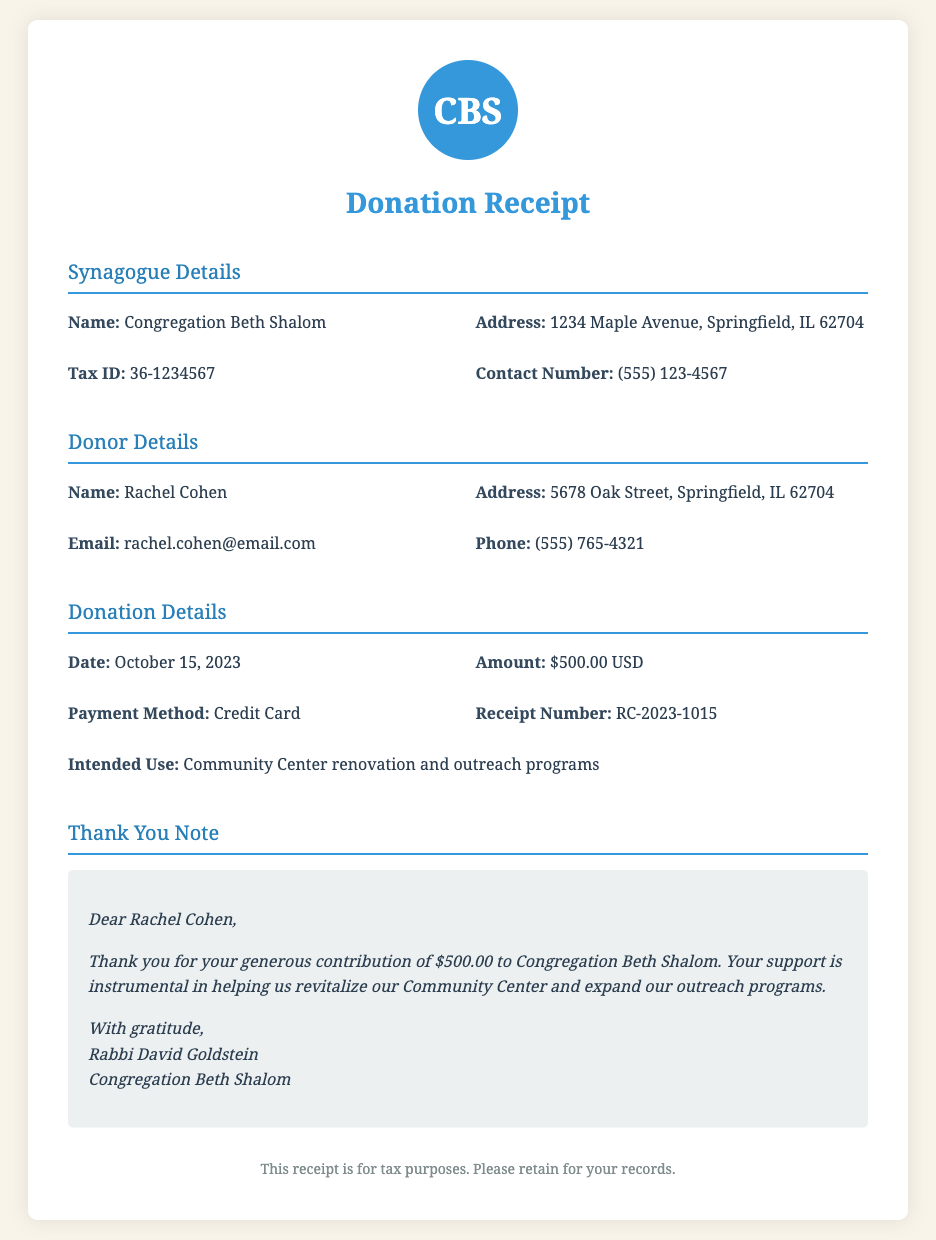What is the name of the synagogue? The name of the synagogue is specified in the document as Congregation Beth Shalom.
Answer: Congregation Beth Shalom What is the amount of the donation? The total donation amount listed in the document is provided under Donation Details.
Answer: $500.00 USD Who is the donor? The donor's name is clearly mentioned in the Donor Details section of the document.
Answer: Rachel Cohen What was the intended use of the funds? The intended use of the funds is specifically detailed in the Donation Details section.
Answer: Community Center renovation and outreach programs What is the receipt number? The receipt number is part of the Donation Details and is essential for tracking the donation.
Answer: RC-2023-1015 When was the donation made? The date of the donation is provided in the Donation Details section of the document.
Answer: October 15, 2023 What payment method was used? The payment method for the donation is mentioned in the Donation Details section.
Answer: Credit Card What was the donor's email address? The donor's email is listed in the Donor Details section for contact purposes.
Answer: rachel.cohen@email.com Who signed the thank-you note? The signature in the thank-you note indicates who expressed gratitude for the donation.
Answer: Rabbi David Goldstein 